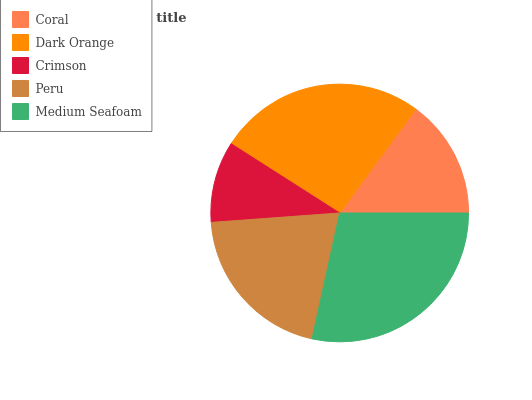Is Crimson the minimum?
Answer yes or no. Yes. Is Medium Seafoam the maximum?
Answer yes or no. Yes. Is Dark Orange the minimum?
Answer yes or no. No. Is Dark Orange the maximum?
Answer yes or no. No. Is Dark Orange greater than Coral?
Answer yes or no. Yes. Is Coral less than Dark Orange?
Answer yes or no. Yes. Is Coral greater than Dark Orange?
Answer yes or no. No. Is Dark Orange less than Coral?
Answer yes or no. No. Is Peru the high median?
Answer yes or no. Yes. Is Peru the low median?
Answer yes or no. Yes. Is Crimson the high median?
Answer yes or no. No. Is Crimson the low median?
Answer yes or no. No. 